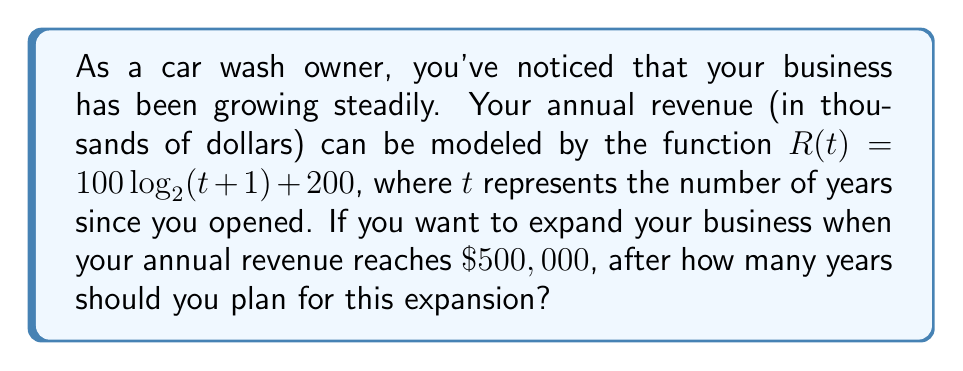Could you help me with this problem? To solve this problem, we need to follow these steps:

1) We're looking for the time $t$ when the revenue $R(t)$ reaches $500,000. This means we need to solve the equation:

   $R(t) = 500$

2) Substituting the given function:

   $100 \log_2(t+1) + 200 = 500$

3) Subtract 200 from both sides:

   $100 \log_2(t+1) = 300$

4) Divide both sides by 100:

   $\log_2(t+1) = 3$

5) To solve for $t$, we need to apply the inverse function of $\log_2$, which is $2^x$:

   $2^{\log_2(t+1)} = 2^3$

6) The left side simplifies to just $(t+1)$:

   $t + 1 = 2^3 = 8$

7) Subtract 1 from both sides:

   $t = 7$

Therefore, you should plan for expansion after 7 years of operation.
Answer: 7 years 